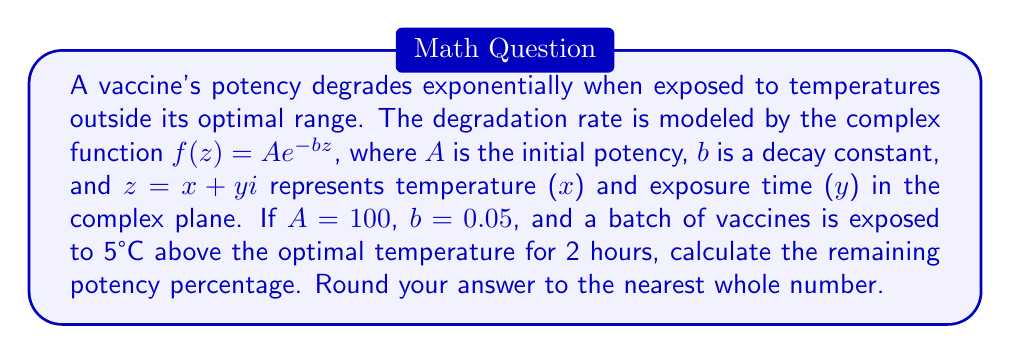Solve this math problem. To solve this problem, we need to follow these steps:

1) We're given the complex function $f(z) = Ae^{-bz}$ where:
   $A = 100$ (initial potency)
   $b = 0.05$ (decay constant)
   $z = x + yi$ (complex number representing temperature and time)

2) In this case:
   $x = 5$ (5°C above optimal temperature)
   $y = 2$ (2 hours of exposure)

3) So, $z = 5 + 2i$

4) We need to calculate $f(5 + 2i)$:

   $f(5 + 2i) = 100e^{-0.05(5 + 2i)}$

5) Using the properties of complex exponents:

   $e^{a+bi} = e^a(\cos b + i\sin b)$

   Here, $-0.05(5 + 2i) = -0.25 - 0.1i$

6) So, our calculation becomes:

   $100e^{-0.25}(\cos(-0.1) + i\sin(-0.1))$

7) Evaluating:
   $e^{-0.25} \approx 0.7788$
   $\cos(-0.1) \approx 0.9950$
   $\sin(-0.1) \approx -0.0998$

8) Therefore:

   $f(5 + 2i) \approx 100 * 0.7788 * (0.9950 - 0.0998i)$

9) The magnitude of this complex number represents the remaining potency:

   $|f(5 + 2i)| \approx 100 * 0.7788 * \sqrt{0.9950^2 + (-0.0998)^2}$
                $\approx 77.88 * 0.9995$
                $\approx 77.84$

10) As a percentage of the initial potency:

    $\frac{77.84}{100} * 100\% \approx 77.84\%$

11) Rounding to the nearest whole number: 78%
Answer: 78% 